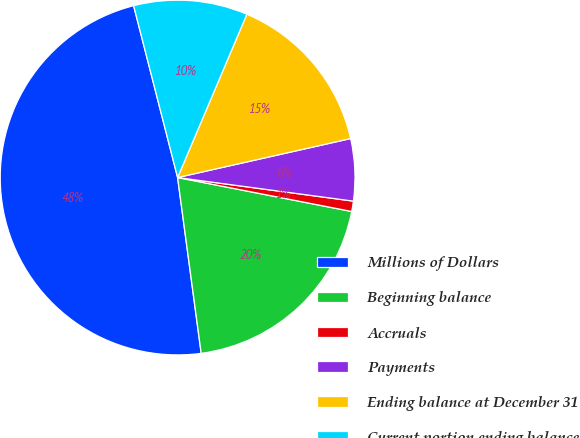<chart> <loc_0><loc_0><loc_500><loc_500><pie_chart><fcel>Millions of Dollars<fcel>Beginning balance<fcel>Accruals<fcel>Payments<fcel>Ending balance at December 31<fcel>Current portion ending balance<nl><fcel>48.13%<fcel>19.81%<fcel>0.94%<fcel>5.65%<fcel>15.09%<fcel>10.37%<nl></chart> 